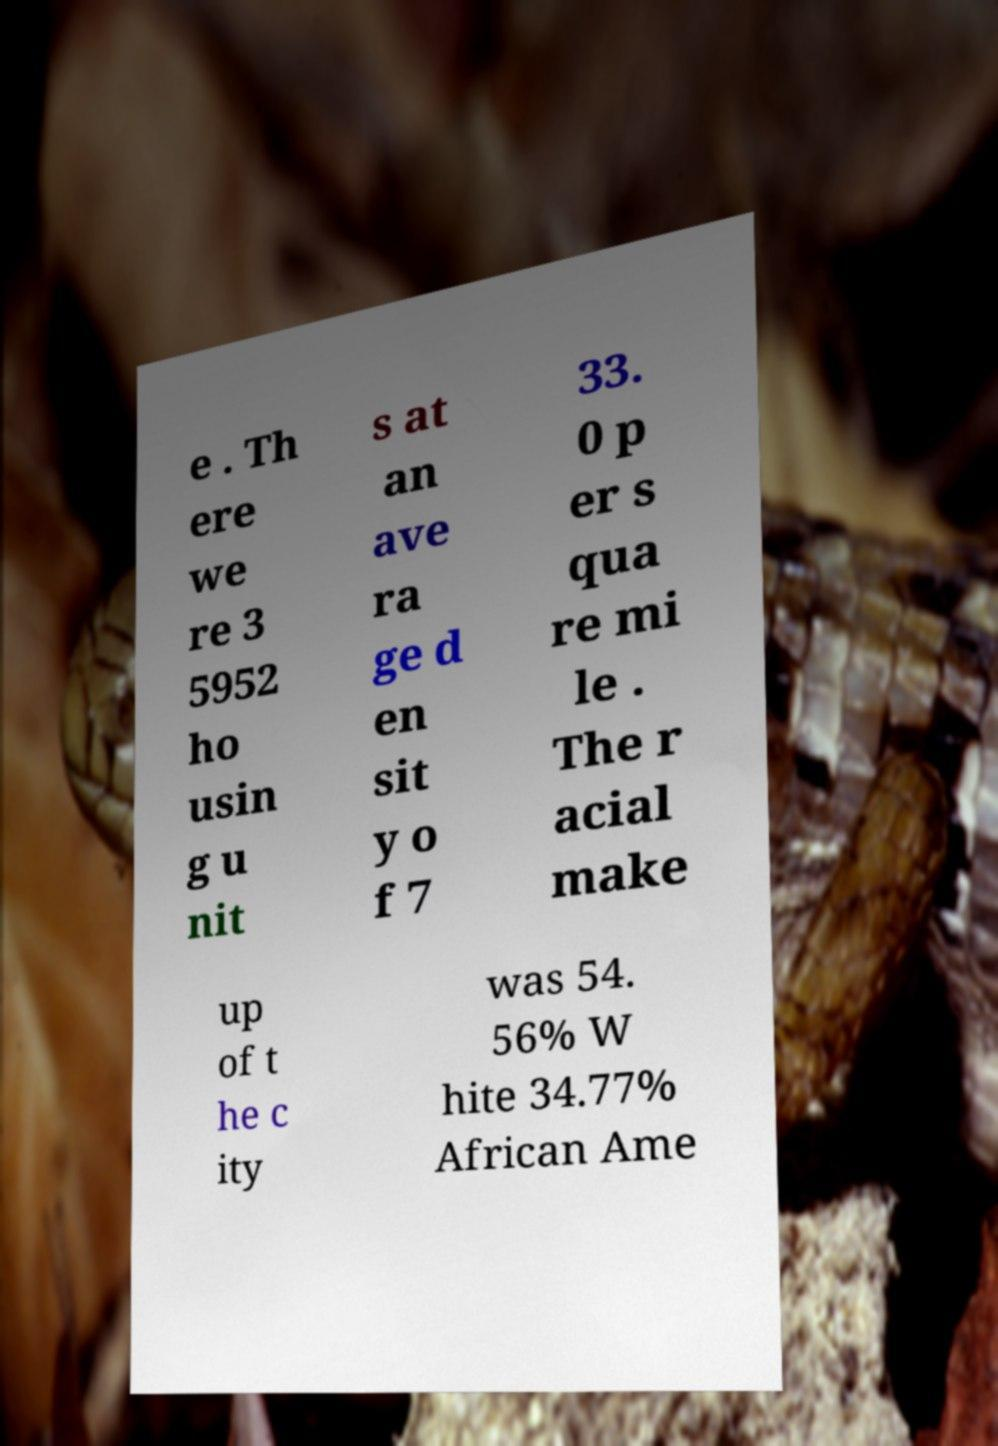Please read and relay the text visible in this image. What does it say? e . Th ere we re 3 5952 ho usin g u nit s at an ave ra ge d en sit y o f 7 33. 0 p er s qua re mi le . The r acial make up of t he c ity was 54. 56% W hite 34.77% African Ame 